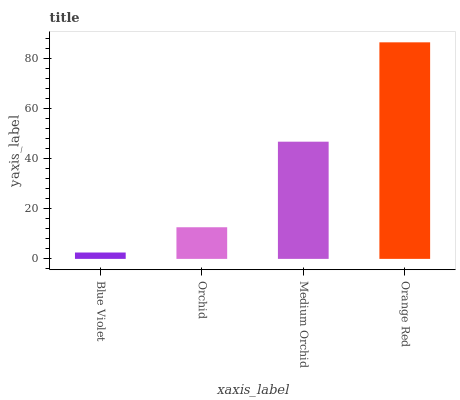Is Blue Violet the minimum?
Answer yes or no. Yes. Is Orange Red the maximum?
Answer yes or no. Yes. Is Orchid the minimum?
Answer yes or no. No. Is Orchid the maximum?
Answer yes or no. No. Is Orchid greater than Blue Violet?
Answer yes or no. Yes. Is Blue Violet less than Orchid?
Answer yes or no. Yes. Is Blue Violet greater than Orchid?
Answer yes or no. No. Is Orchid less than Blue Violet?
Answer yes or no. No. Is Medium Orchid the high median?
Answer yes or no. Yes. Is Orchid the low median?
Answer yes or no. Yes. Is Orchid the high median?
Answer yes or no. No. Is Orange Red the low median?
Answer yes or no. No. 